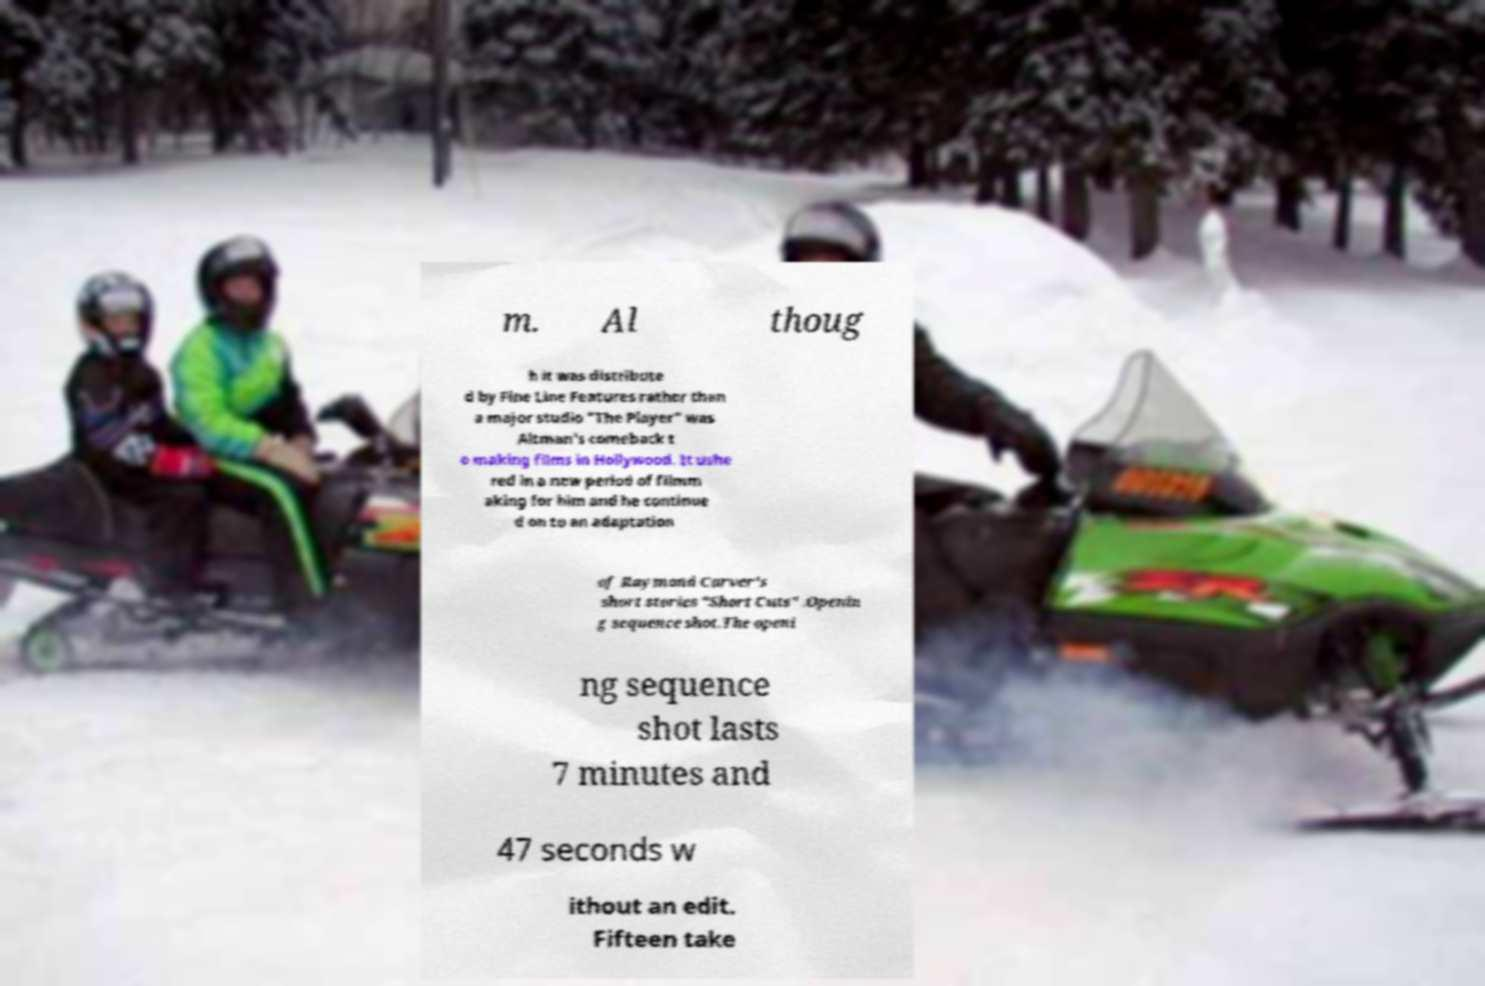What messages or text are displayed in this image? I need them in a readable, typed format. m. Al thoug h it was distribute d by Fine Line Features rather than a major studio "The Player" was Altman's comeback t o making films in Hollywood. It ushe red in a new period of filmm aking for him and he continue d on to an adaptation of Raymond Carver's short stories "Short Cuts" .Openin g sequence shot.The openi ng sequence shot lasts 7 minutes and 47 seconds w ithout an edit. Fifteen take 